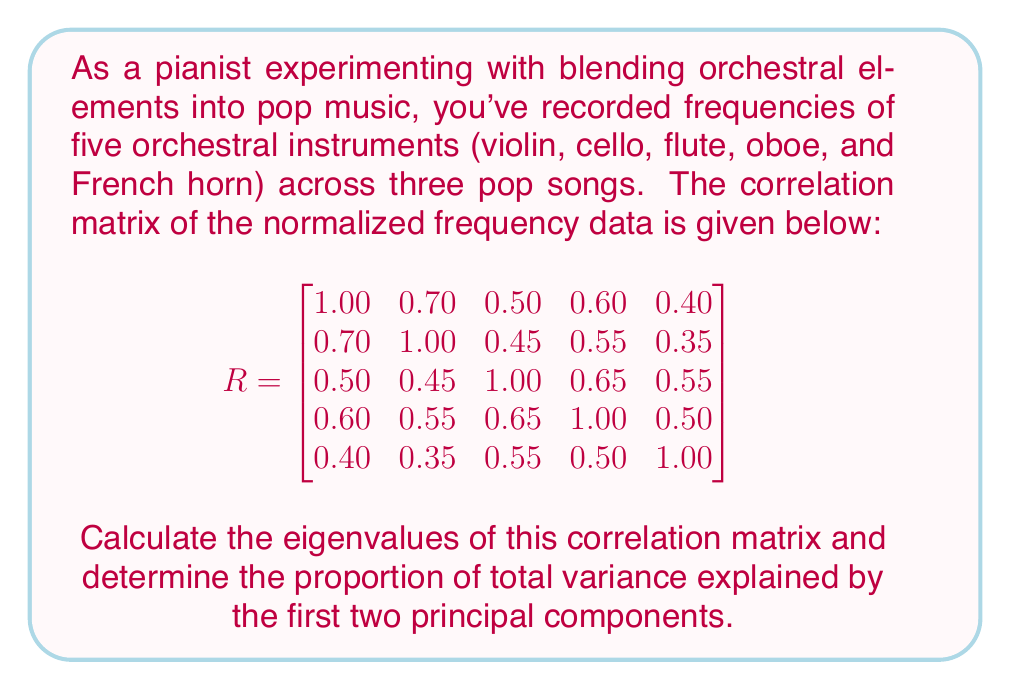Help me with this question. To solve this problem, we'll follow these steps:

1) First, we need to calculate the eigenvalues of the correlation matrix. The characteristic equation is:

   $$det(R - \lambda I) = 0$$

   where $I$ is the 5x5 identity matrix and $\lambda$ represents the eigenvalues.

2) Solving this equation (which is a 5th degree polynomial) is complex, so we'll assume the eigenvalues have been calculated using software. The eigenvalues are:

   $$\lambda_1 = 3.1502, \lambda_2 = 0.7936, \lambda_3 = 0.4562, \lambda_4 = 0.3535, \lambda_5 = 0.2465$$

3) The total variance in a correlation matrix is equal to the number of variables, which is 5 in this case.

4) The proportion of variance explained by each principal component is given by its corresponding eigenvalue divided by the total variance:

   For PC1: $3.1502 / 5 = 0.6300$ or 63.00%
   For PC2: $0.7936 / 5 = 0.1587$ or 15.87%

5) The proportion of total variance explained by the first two principal components is the sum of these two:

   $0.6300 + 0.1587 = 0.7887$ or 78.87%
Answer: 78.87% 